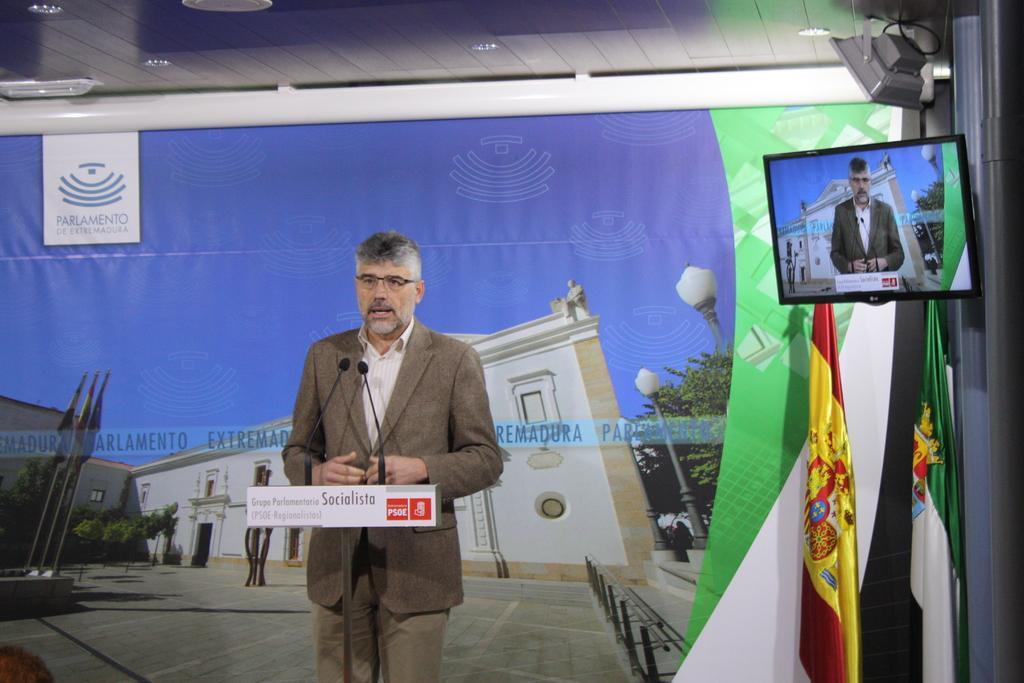Please provide a concise description of this image. In the center of the image we can see a man standing and talking, before him there are mics. On the right we can see a screen placed on the wall. There are flags. In the background there is a banner. At the top we can see lights. 